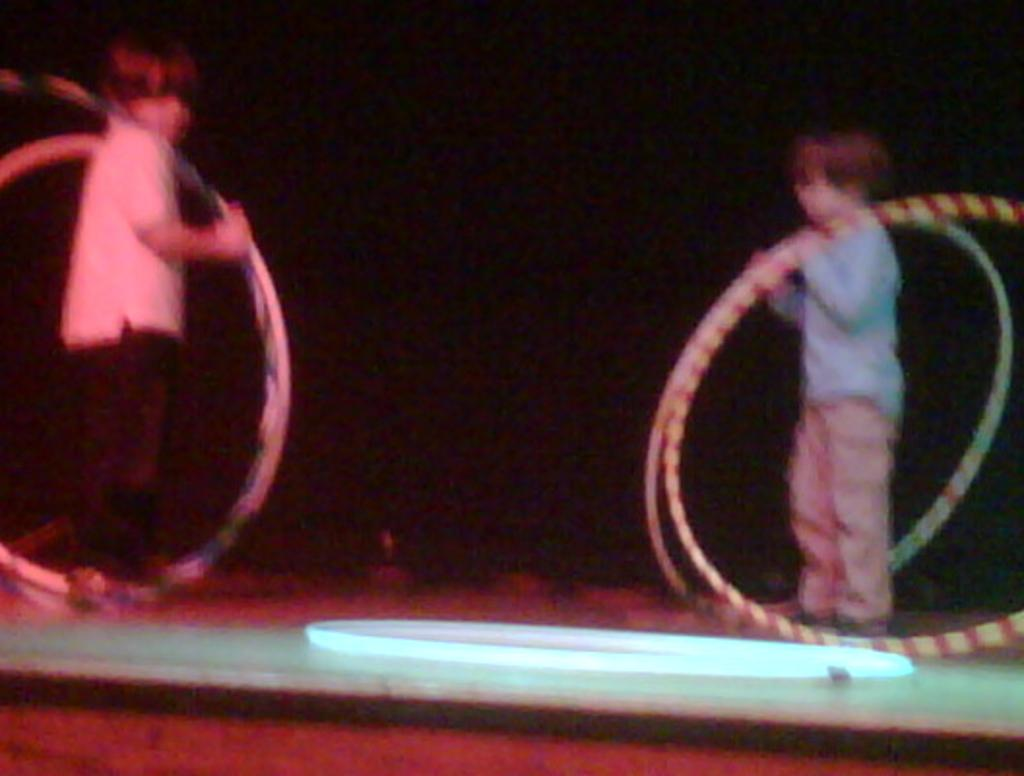How many boys are present in the image? There are two boys in the image. Where are the boys positioned in the image? The boys are standing on the right and left sides of the image. What are the boys holding in their hands? The boys are holding rings in their hands. What type of seat can be seen in the image? There is no seat present in the image. Can you tell me how many apples the boys are holding in the image? The boys are not holding any apples in the image; they are holding rings. 